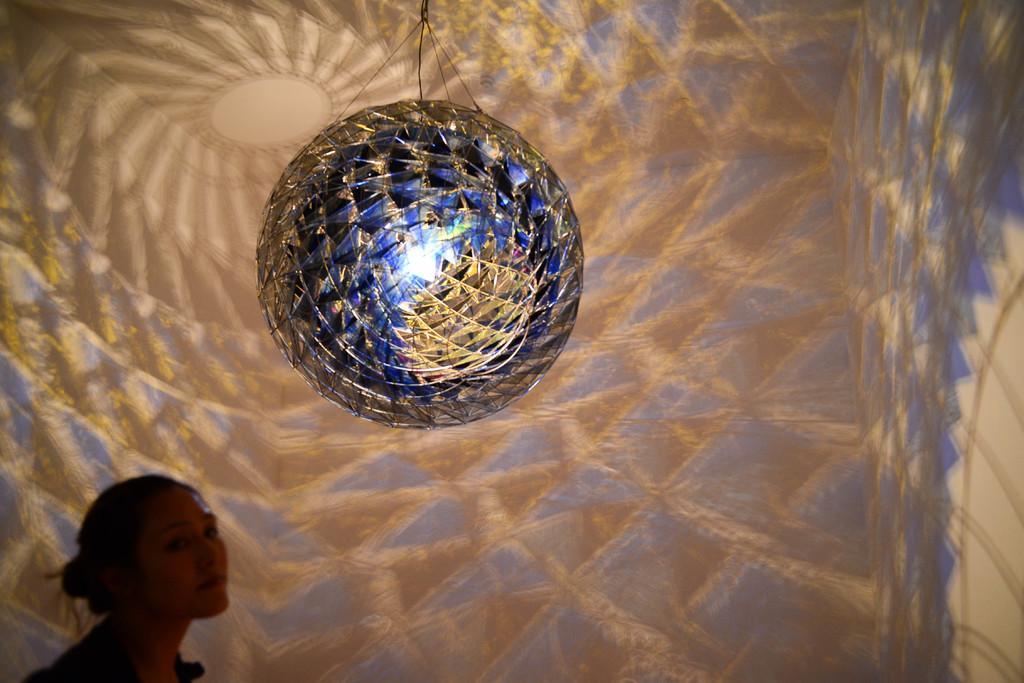What shape is the object in the picture? The object in the picture is round. Who is present in the picture? There is a woman in the picture. What can be seen in the background of the picture? There is a wall with designs in the background of the picture. Can you see the woman's friend in the garden in the image? There is no garden or friend present in the image; it only features a round object, a woman, and a wall with designs in the background. 